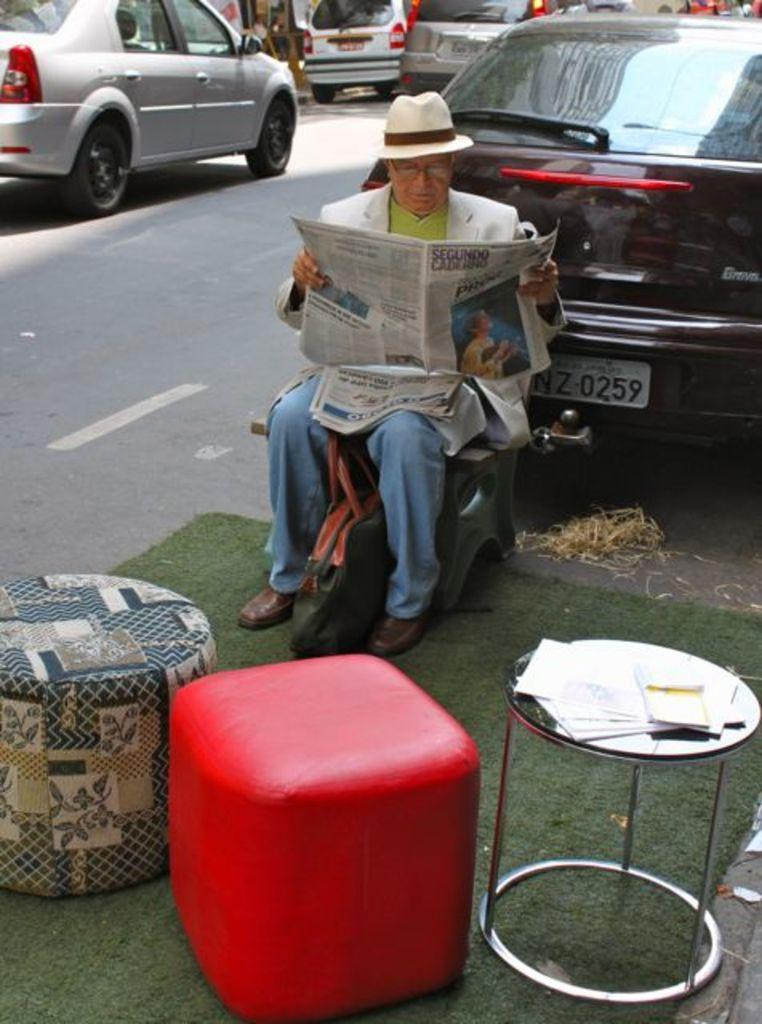What is the person in the image holding? The person is holding a paper in the image. What can be seen in the background of the image? There are vehicles on the road in the image. What is in front of the person in the image? There are chairs in front of the person in the image. How many times did the person attack the vehicles on the road in the image? There is no indication of an attack in the image; the person is simply holding a paper, and there are vehicles on the road. 